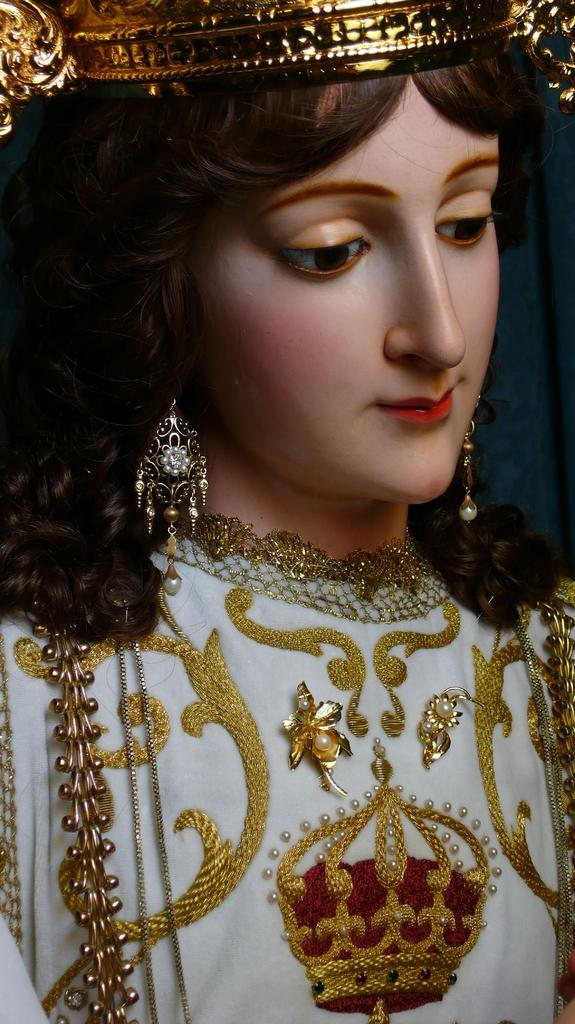What is the main subject of the image? The main subject of the image is a sculpture of a girl. What accessories does the sculpture have? The sculpture has earrings and a crown on its head. What type of clothing is the sculpture wearing? The sculpture has a dress. How many friends can be seen with the sculpture in the image? There are no friends present in the image, as it only features the sculpture of a girl. 